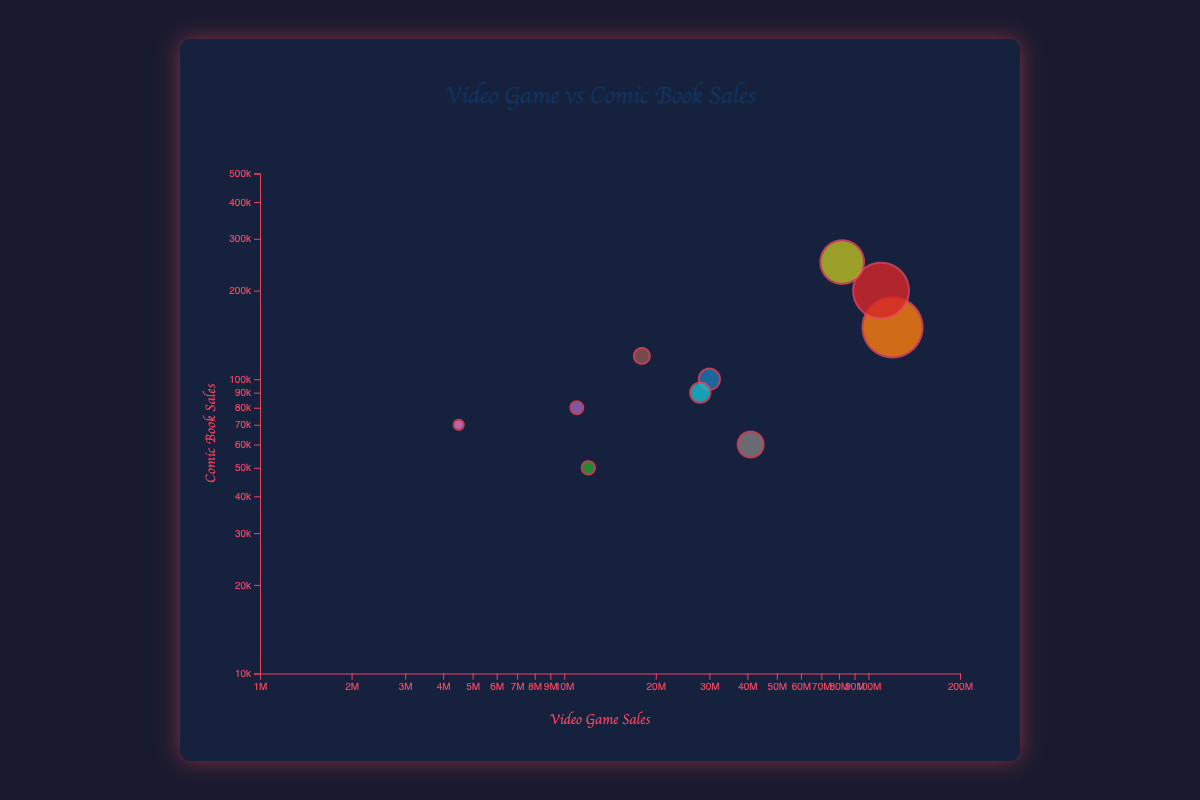what is the title of the figure? The title of the figure can be seen at the top, centered above the chart. It reads: "Video Game vs Comic Book Sales"
Answer: Video Game vs Comic Book Sales how many data points are represented in the figure? Each bubble in the chart represents a single data point. By counting the bubbles, we can determine that there are 10 data points represented in the figure.
Answer: 10 which bubble has the highest comic book sales? The y-axis represents the comic book sales, and the bubble with the highest position on this axis is "Halo: Uprising" with comic book sales of 250,000.
Answer: Halo: Uprising which video game title has the smallest sales in the figure? The x-axis represents the video game sales. The bubble farthest to the left represents "Dragon Age," which has video game sales of 4,500,000.
Answer: Dragon Age how do the sizes of the bubbles represent information? The sizes of the bubbles are proportional to the video game sales. Larger bubbles indicate higher video game sales, while smaller bubbles indicate lower sales.
Answer: Sales magnitude identify the bubble with the largest size (representing the highest video game sales). What are its corresponding comic book sales? The largest bubble represents "Assassin's Creed" with video game sales of 120,000,000. Its corresponding comic book sales are 150,000.
Answer: 150,000 what is the approximate difference in video game sales between 'Resident Evil' and 'The Witcher 3: Wild Hunt'? "Resident Evil" has video game sales of 110,000,000, and "The Witcher 3: Wild Hunt" has 30,000,000. The difference is 110,000,000 - 30,000,000 = 80,000,000.
Answer: 80,000,000 which title has higher comic book sales: 'Mass Effect' or 'Tomb Raider'? By comparing the y-coordinates of the bubbles for 'Mass Effect' and 'Tomb Raider,' it's clear that 'Mass Effect' has higher comic book sales (120,000) compared to 'Tomb Raider' (80,000).
Answer: Mass Effect are there any bubbles that have both video game sales and comic book sales above 100,000,000 and 100,000 respectively? From the chart, "Resident Evil" meets this criterion with video game sales of 110,000,000 and comic book sales of 200,000.
Answer: Resident Evil which data point has the smallest radius and what does it represent? The smallest radius represents the smallest video game sales. The bubble size for 'Dragon Age' is the smallest, which corresponds to video game sales of 4,500,000.
Answer: Dragon Age 